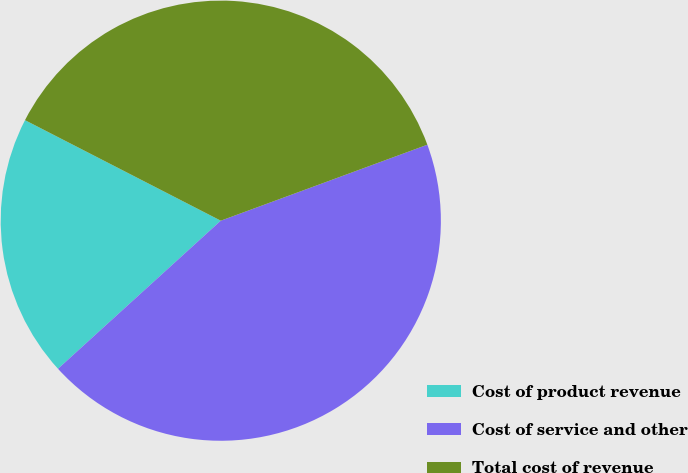Convert chart to OTSL. <chart><loc_0><loc_0><loc_500><loc_500><pie_chart><fcel>Cost of product revenue<fcel>Cost of service and other<fcel>Total cost of revenue<nl><fcel>19.3%<fcel>43.86%<fcel>36.84%<nl></chart> 